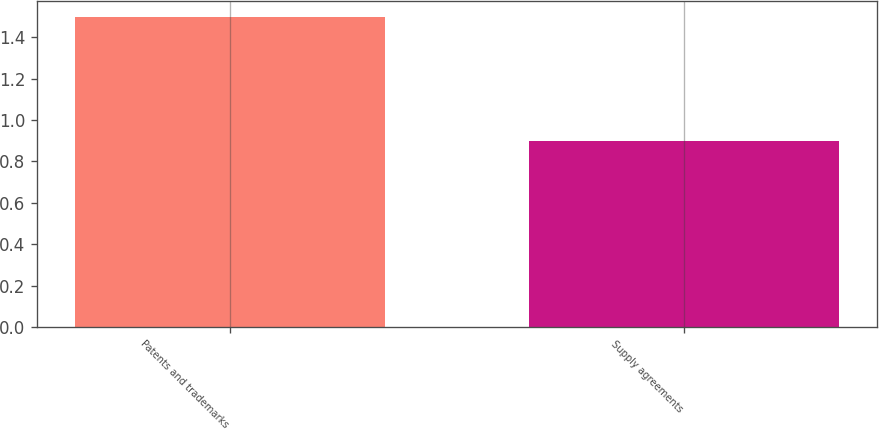Convert chart. <chart><loc_0><loc_0><loc_500><loc_500><bar_chart><fcel>Patents and trademarks<fcel>Supply agreements<nl><fcel>1.5<fcel>0.9<nl></chart> 